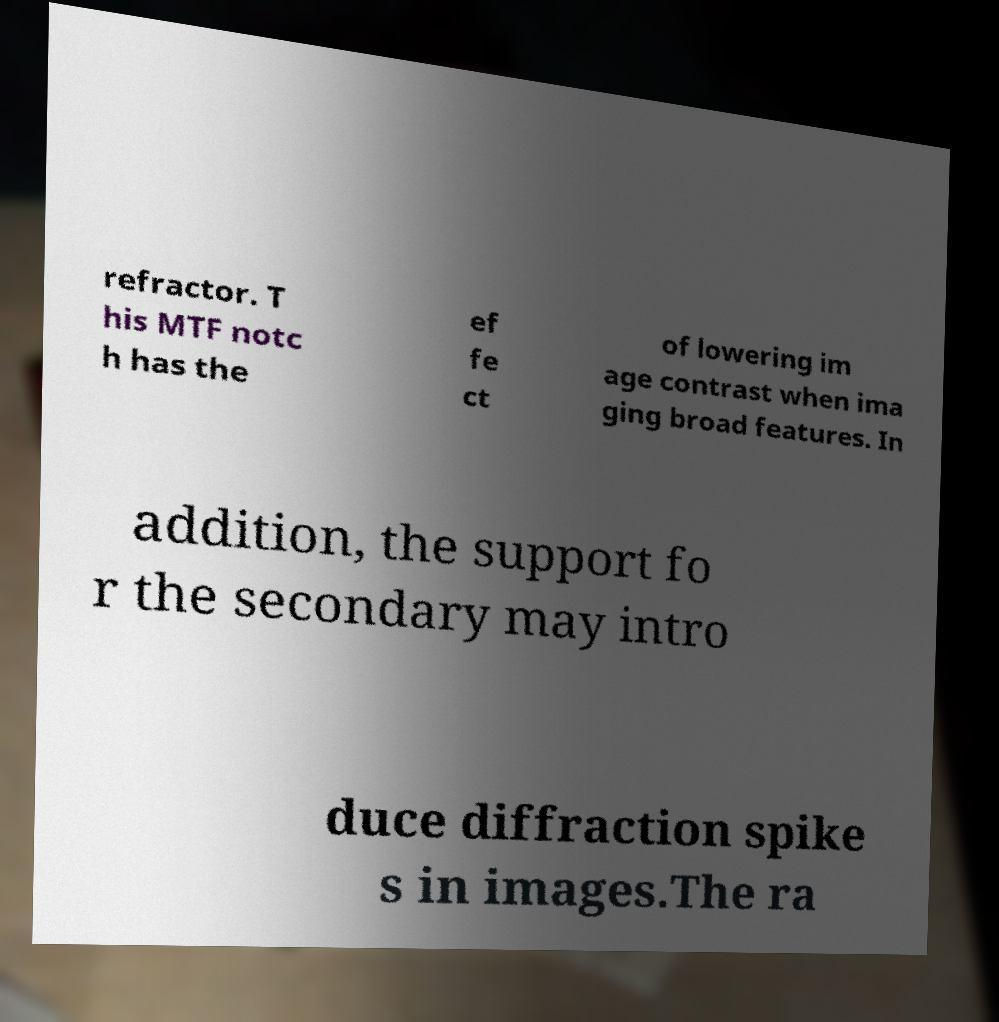Could you assist in decoding the text presented in this image and type it out clearly? refractor. T his MTF notc h has the ef fe ct of lowering im age contrast when ima ging broad features. In addition, the support fo r the secondary may intro duce diffraction spike s in images.The ra 